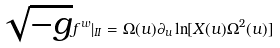Convert formula to latex. <formula><loc_0><loc_0><loc_500><loc_500>\sqrt { - g } f ^ { w } | _ { I I } = \Omega ( u ) \partial _ { u } \ln [ X ( u ) \Omega ^ { 2 } ( u ) ]</formula> 